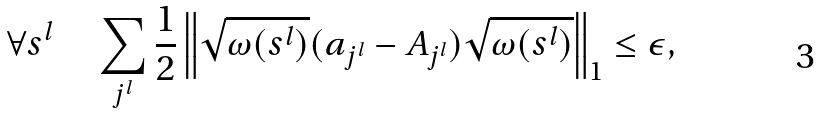Convert formula to latex. <formula><loc_0><loc_0><loc_500><loc_500>\forall s ^ { l } \quad \sum _ { j ^ { l } } \frac { 1 } { 2 } \left \| \sqrt { \omega ( s ^ { l } ) } ( a _ { j ^ { l } } - A _ { j ^ { l } } ) \sqrt { \omega ( s ^ { l } ) } \right \| _ { 1 } \leq \epsilon ,</formula> 